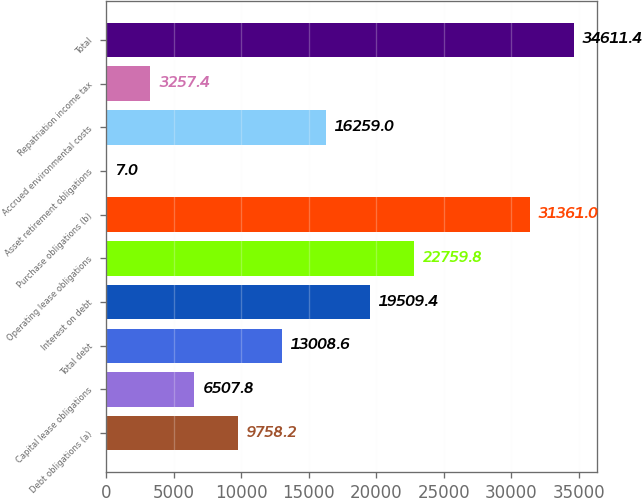Convert chart to OTSL. <chart><loc_0><loc_0><loc_500><loc_500><bar_chart><fcel>Debt obligations (a)<fcel>Capital lease obligations<fcel>Total debt<fcel>Interest on debt<fcel>Operating lease obligations<fcel>Purchase obligations (b)<fcel>Asset retirement obligations<fcel>Accrued environmental costs<fcel>Repatriation income tax<fcel>Total<nl><fcel>9758.2<fcel>6507.8<fcel>13008.6<fcel>19509.4<fcel>22759.8<fcel>31361<fcel>7<fcel>16259<fcel>3257.4<fcel>34611.4<nl></chart> 